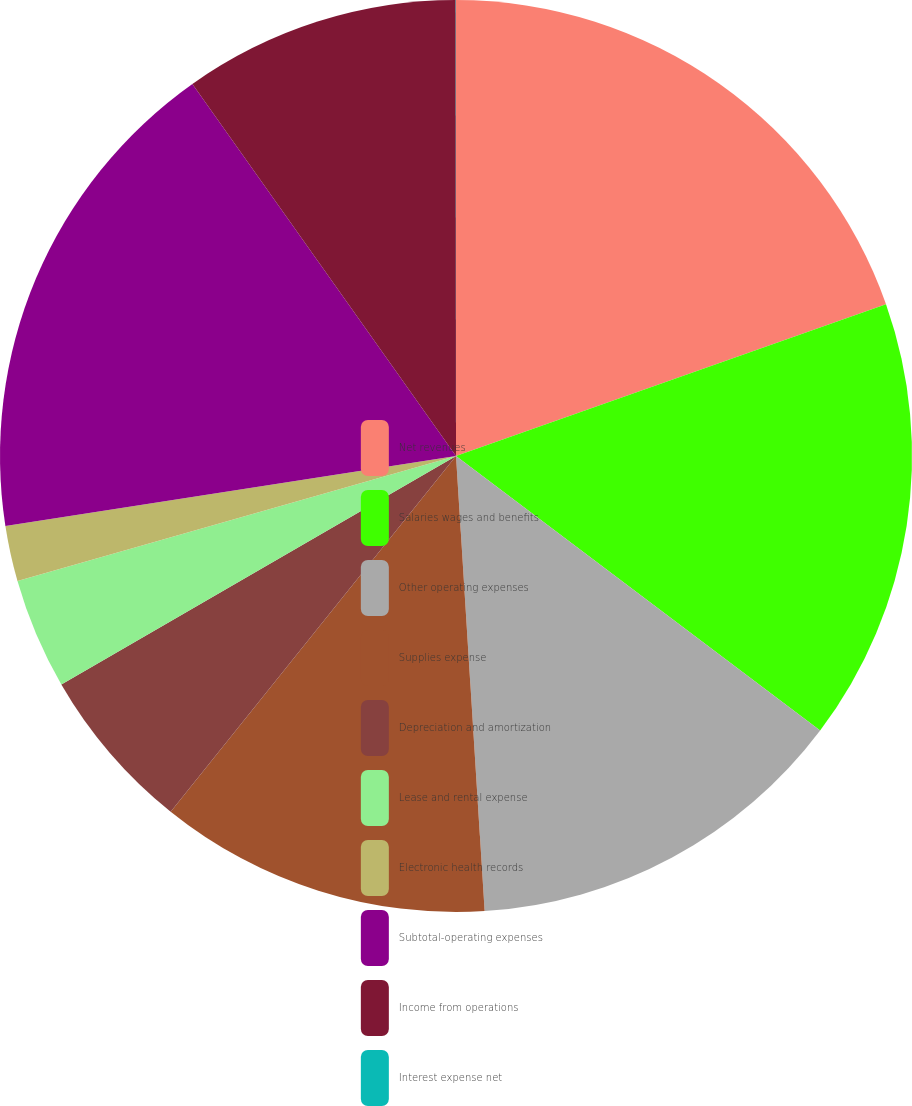Convert chart to OTSL. <chart><loc_0><loc_0><loc_500><loc_500><pie_chart><fcel>Net revenues<fcel>Salaries wages and benefits<fcel>Other operating expenses<fcel>Supplies expense<fcel>Depreciation and amortization<fcel>Lease and rental expense<fcel>Electronic health records<fcel>Subtotal-operating expenses<fcel>Income from operations<fcel>Interest expense net<nl><fcel>19.6%<fcel>15.68%<fcel>13.72%<fcel>11.76%<fcel>5.89%<fcel>3.93%<fcel>1.97%<fcel>17.64%<fcel>9.8%<fcel>0.01%<nl></chart> 